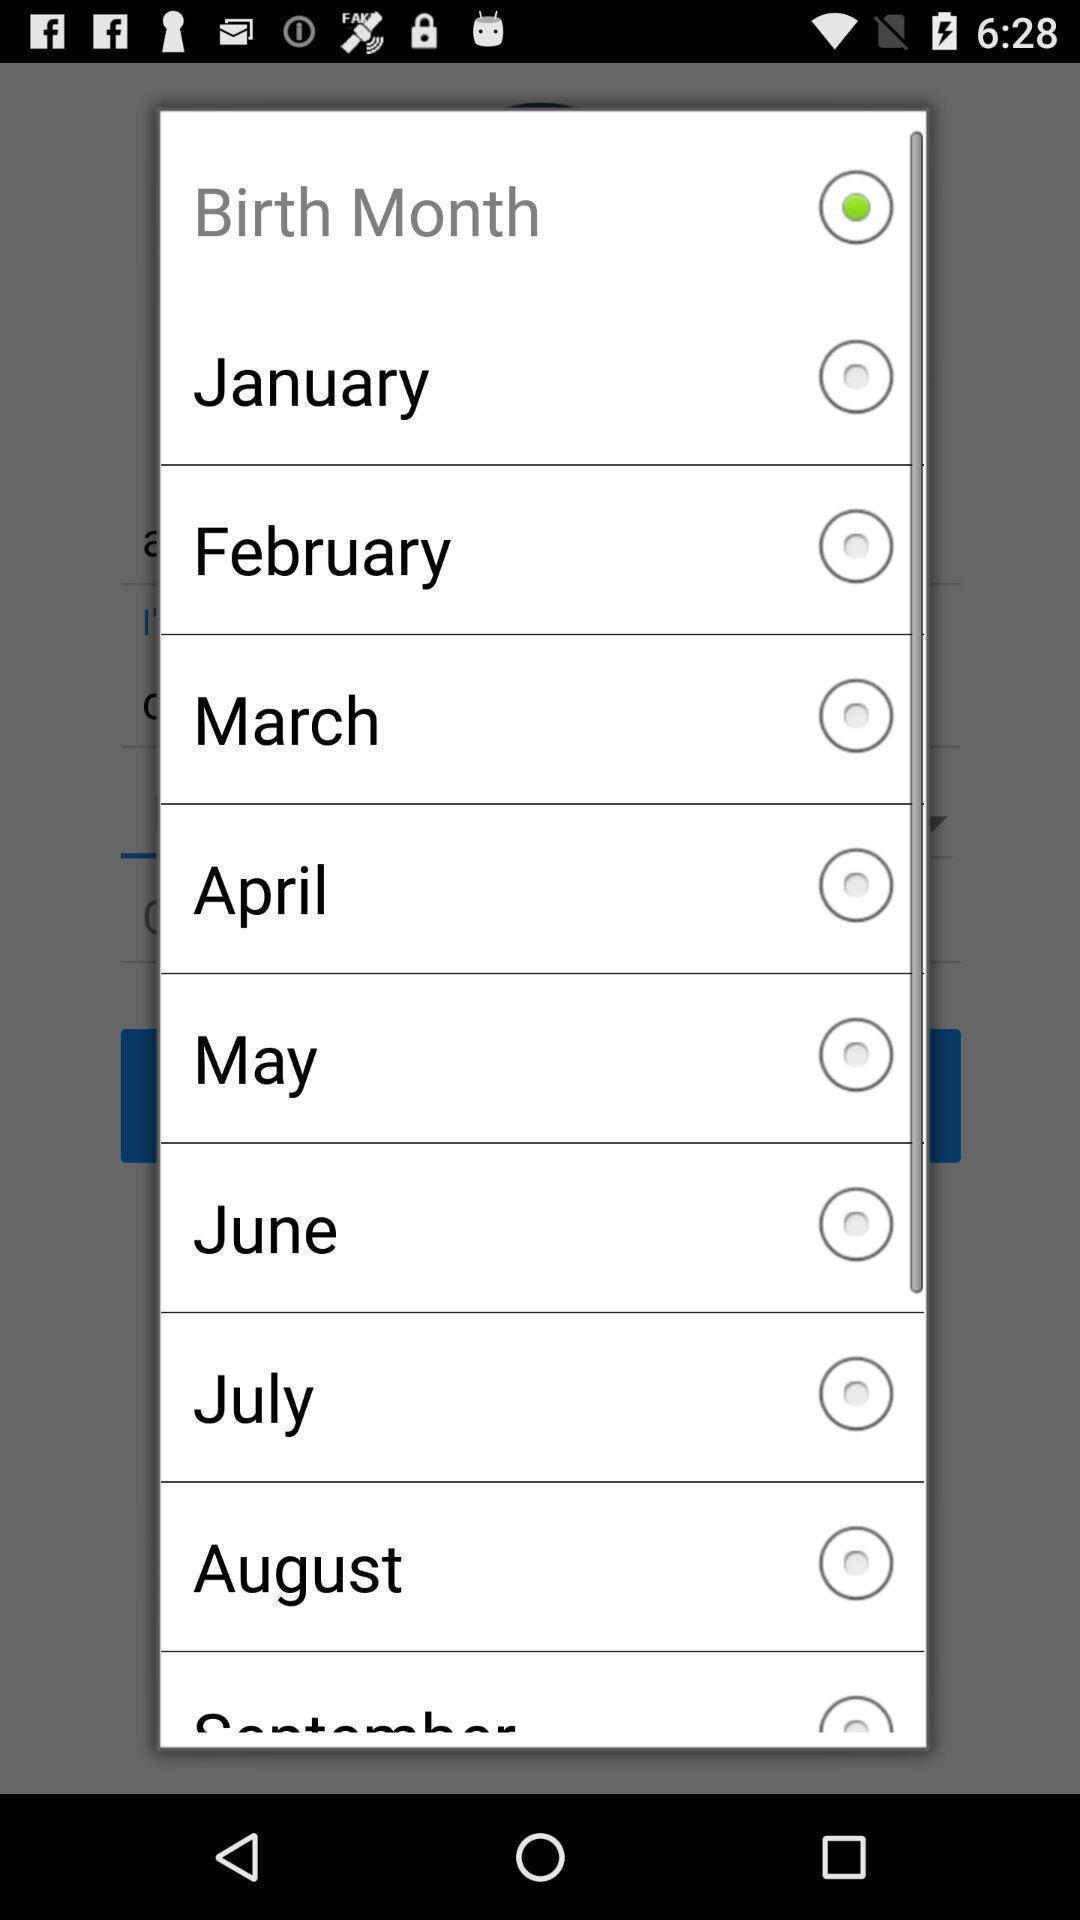Describe this image in words. Pop-up to select the birth month. 